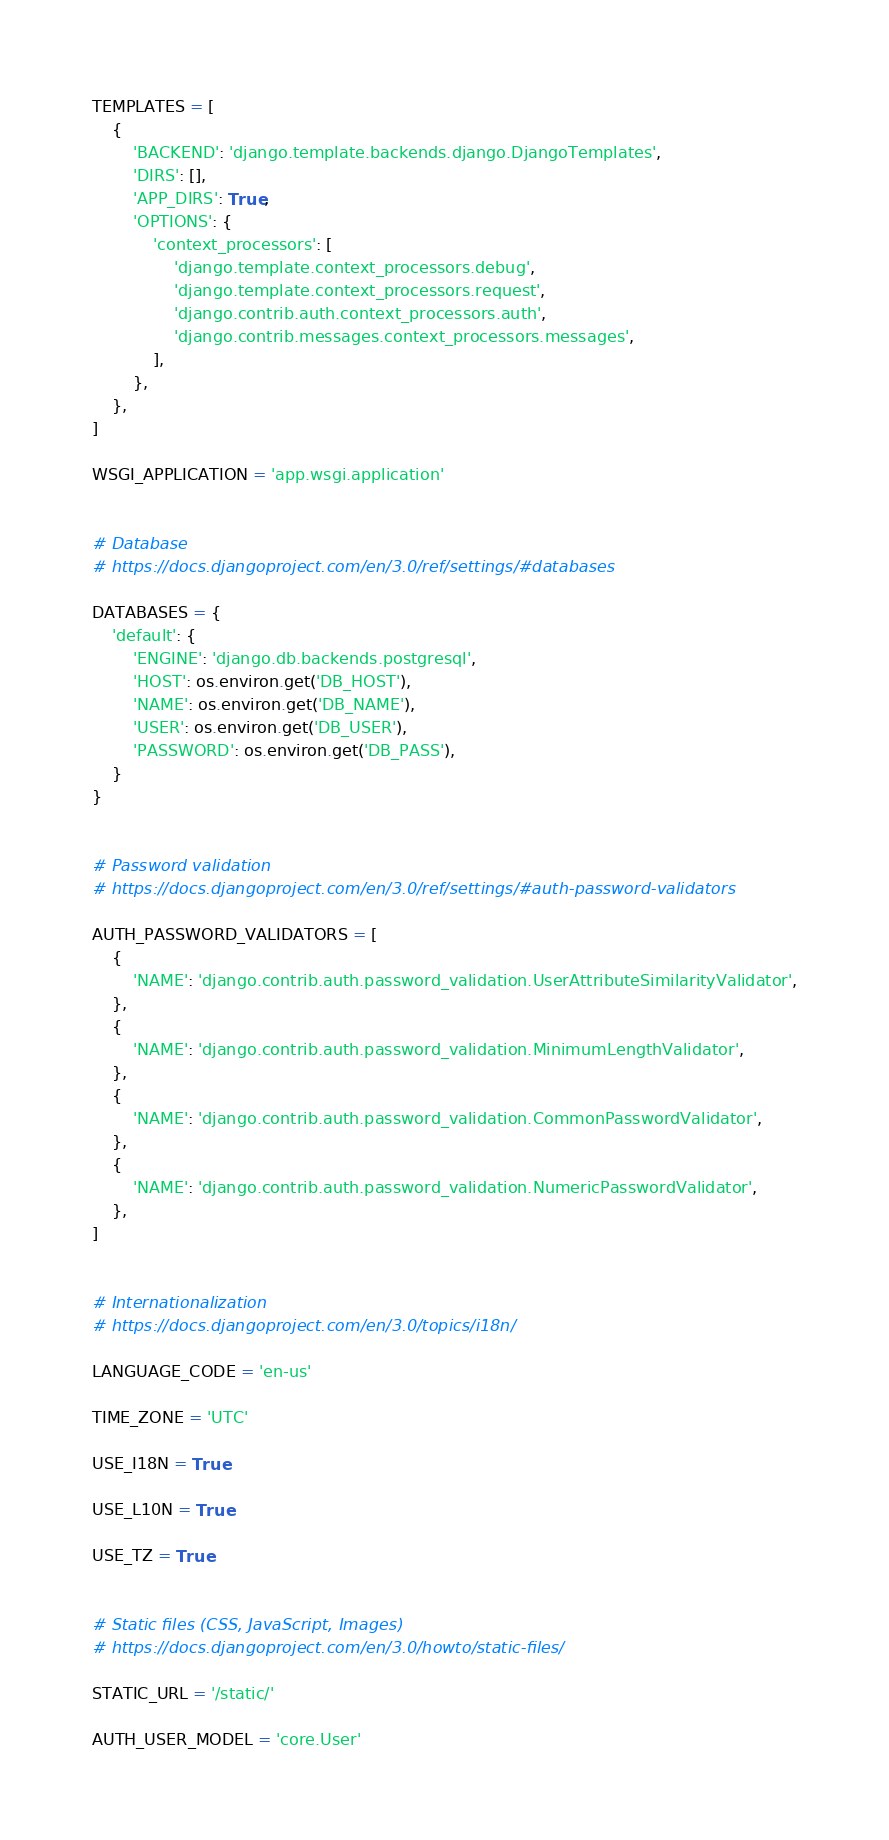<code> <loc_0><loc_0><loc_500><loc_500><_Python_>TEMPLATES = [
    {
        'BACKEND': 'django.template.backends.django.DjangoTemplates',
        'DIRS': [],
        'APP_DIRS': True,
        'OPTIONS': {
            'context_processors': [
                'django.template.context_processors.debug',
                'django.template.context_processors.request',
                'django.contrib.auth.context_processors.auth',
                'django.contrib.messages.context_processors.messages',
            ],
        },
    },
]

WSGI_APPLICATION = 'app.wsgi.application'


# Database
# https://docs.djangoproject.com/en/3.0/ref/settings/#databases

DATABASES = {
    'default': {
        'ENGINE': 'django.db.backends.postgresql',
        'HOST': os.environ.get('DB_HOST'),
        'NAME': os.environ.get('DB_NAME'),
        'USER': os.environ.get('DB_USER'),
        'PASSWORD': os.environ.get('DB_PASS'),
    }
}


# Password validation
# https://docs.djangoproject.com/en/3.0/ref/settings/#auth-password-validators

AUTH_PASSWORD_VALIDATORS = [
    {
        'NAME': 'django.contrib.auth.password_validation.UserAttributeSimilarityValidator',
    },
    {
        'NAME': 'django.contrib.auth.password_validation.MinimumLengthValidator',
    },
    {
        'NAME': 'django.contrib.auth.password_validation.CommonPasswordValidator',
    },
    {
        'NAME': 'django.contrib.auth.password_validation.NumericPasswordValidator',
    },
]


# Internationalization
# https://docs.djangoproject.com/en/3.0/topics/i18n/

LANGUAGE_CODE = 'en-us'

TIME_ZONE = 'UTC'

USE_I18N = True

USE_L10N = True

USE_TZ = True


# Static files (CSS, JavaScript, Images)
# https://docs.djangoproject.com/en/3.0/howto/static-files/

STATIC_URL = '/static/'

AUTH_USER_MODEL = 'core.User'</code> 